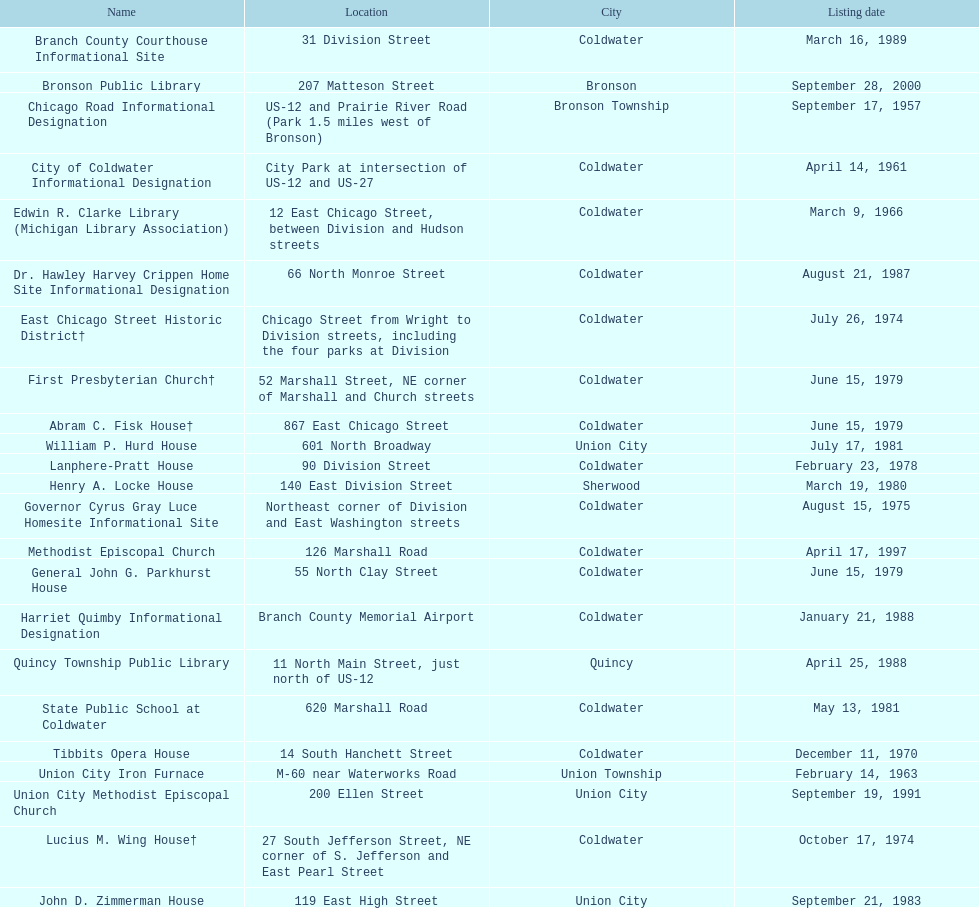How many sites are in coldwater? 15. Give me the full table as a dictionary. {'header': ['Name', 'Location', 'City', 'Listing date'], 'rows': [['Branch County Courthouse Informational Site', '31 Division Street', 'Coldwater', 'March 16, 1989'], ['Bronson Public Library', '207 Matteson Street', 'Bronson', 'September 28, 2000'], ['Chicago Road Informational Designation', 'US-12 and Prairie River Road (Park 1.5 miles west of Bronson)', 'Bronson Township', 'September 17, 1957'], ['City of Coldwater Informational Designation', 'City Park at intersection of US-12 and US-27', 'Coldwater', 'April 14, 1961'], ['Edwin R. Clarke Library (Michigan Library Association)', '12 East Chicago Street, between Division and Hudson streets', 'Coldwater', 'March 9, 1966'], ['Dr. Hawley Harvey Crippen Home Site Informational Designation', '66 North Monroe Street', 'Coldwater', 'August 21, 1987'], ['East Chicago Street Historic District†', 'Chicago Street from Wright to Division streets, including the four parks at Division', 'Coldwater', 'July 26, 1974'], ['First Presbyterian Church†', '52 Marshall Street, NE corner of Marshall and Church streets', 'Coldwater', 'June 15, 1979'], ['Abram C. Fisk House†', '867 East Chicago Street', 'Coldwater', 'June 15, 1979'], ['William P. Hurd House', '601 North Broadway', 'Union City', 'July 17, 1981'], ['Lanphere-Pratt House', '90 Division Street', 'Coldwater', 'February 23, 1978'], ['Henry A. Locke House', '140 East Division Street', 'Sherwood', 'March 19, 1980'], ['Governor Cyrus Gray Luce Homesite Informational Site', 'Northeast corner of Division and East Washington streets', 'Coldwater', 'August 15, 1975'], ['Methodist Episcopal Church', '126 Marshall Road', 'Coldwater', 'April 17, 1997'], ['General John G. Parkhurst House', '55 North Clay Street', 'Coldwater', 'June 15, 1979'], ['Harriet Quimby Informational Designation', 'Branch County Memorial Airport', 'Coldwater', 'January 21, 1988'], ['Quincy Township Public Library', '11 North Main Street, just north of US-12', 'Quincy', 'April 25, 1988'], ['State Public School at Coldwater', '620 Marshall Road', 'Coldwater', 'May 13, 1981'], ['Tibbits Opera House', '14 South Hanchett Street', 'Coldwater', 'December 11, 1970'], ['Union City Iron Furnace', 'M-60 near Waterworks Road', 'Union Township', 'February 14, 1963'], ['Union City Methodist Episcopal Church', '200 Ellen Street', 'Union City', 'September 19, 1991'], ['Lucius M. Wing House†', '27 South Jefferson Street, NE corner of S. Jefferson and East Pearl Street', 'Coldwater', 'October 17, 1974'], ['John D. Zimmerman House', '119 East High Street', 'Union City', 'September 21, 1983']]} 